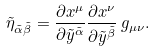<formula> <loc_0><loc_0><loc_500><loc_500>\tilde { \eta } _ { \tilde { \alpha } \tilde { \beta } } = \frac { \partial x ^ { \mu } } { \partial \tilde { y } ^ { \tilde { \alpha } } } \frac { \partial x ^ { \nu } } { \partial \tilde { y } ^ { \tilde { \beta } } } \, g _ { \mu \nu } .</formula> 